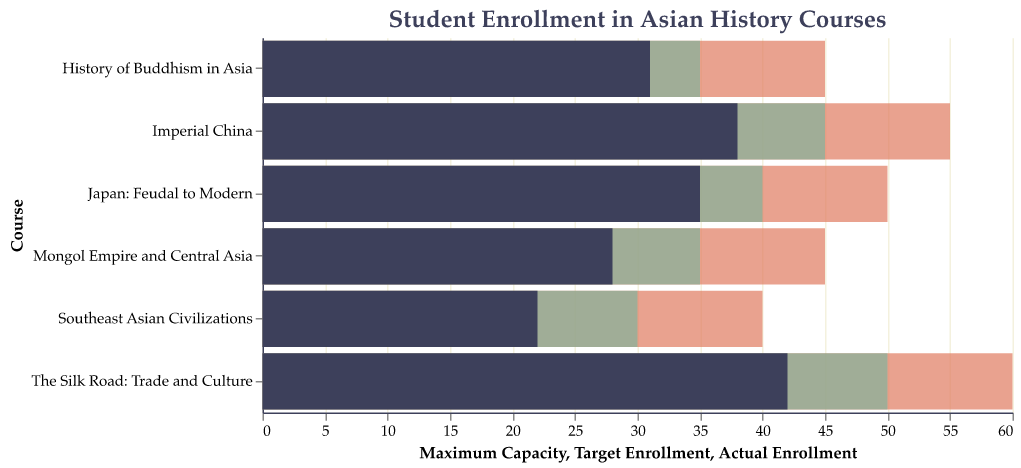What is the title of the figure? The title is located at the top of the figure and typically gives a summary of what the figure represents. In this figure, the title describes the content as "Student Enrollment in Asian History Courses".
Answer: Student Enrollment in Asian History Courses What is the maximum capacity for the course "Japan: Feudal to Modern"? To find the maximum capacity, look for the bar representing the course "Japan: Feudal to Modern" and note the endpoint of the longest bar (indicating maximum capacity). The value is given directly in the figure.
Answer: 50 Which course has the lowest actual enrollment? By examining the shortest dark-colored bar representing actual enrollments in the figure, identify the course associated with this bar.
Answer: Southeast Asian Civilizations How many courses have an actual enrollment below their target enrollment? Compare the length of the dark-colored bar (actual enrollment) with the succeeding lighter-colored bar (target enrollment) for each course. Count the number of courses where the dark-colored bar is shorter than the lighter-colored bar.
Answer: Six courses What is the difference between the target enrollment and the actual enrollment for the course "Imperial China"? Locate the bars representing "Imperial China". Subtract the actual enrollment (length of dark-colored bar) from the target enrollment (length of lighter-colored bar): 45 - 38 = 7.
Answer: 7 Which course is closest to reaching its maximum capacity based on actual enrollment? Evaluate the ratio of actual enrollment to maximum capacity for each course by comparing the dark-colored bar (actual) to the longest bar (maximum capacity). The course with the highest proportion is closest.
Answer: The Silk Road: Trade and Culture Are there any courses where the actual enrollment exceeds the target enrollment? If so, which ones? Compare the dark-colored bars (actual enrollment) with the lighter-colored bars (target enrollment) for each course. Identify if any dark-colored bar extends beyond its corresponding lighter-colored bar.
Answer: None What is the range of maximum capacities across all courses? Find the difference between the highest maximum capacity and the lowest maximum capacity by comparing the lengths of the longest bars. 60 (highest) - 40 (lowest).
Answer: 20 Which courses have both their actual enrollments and target enrollments below the course "The Silk Road: Trade and Culture"? Identify and compare the lengths of the dark-colored and lighter-colored bars for each course against those of "The Silk Road: Trade and Culture". Only courses where both bars are shorter qualify.
Answer: Mongol Empire and Central Asia, Southeast Asian Civilizations, History of Buddhism in Asia What is the average target enrollment across all courses? Sum the target enrollments (50 + 45 + 35 + 40 + 30 + 35 = 235) and divide by the number of courses (6).
Answer: 39 